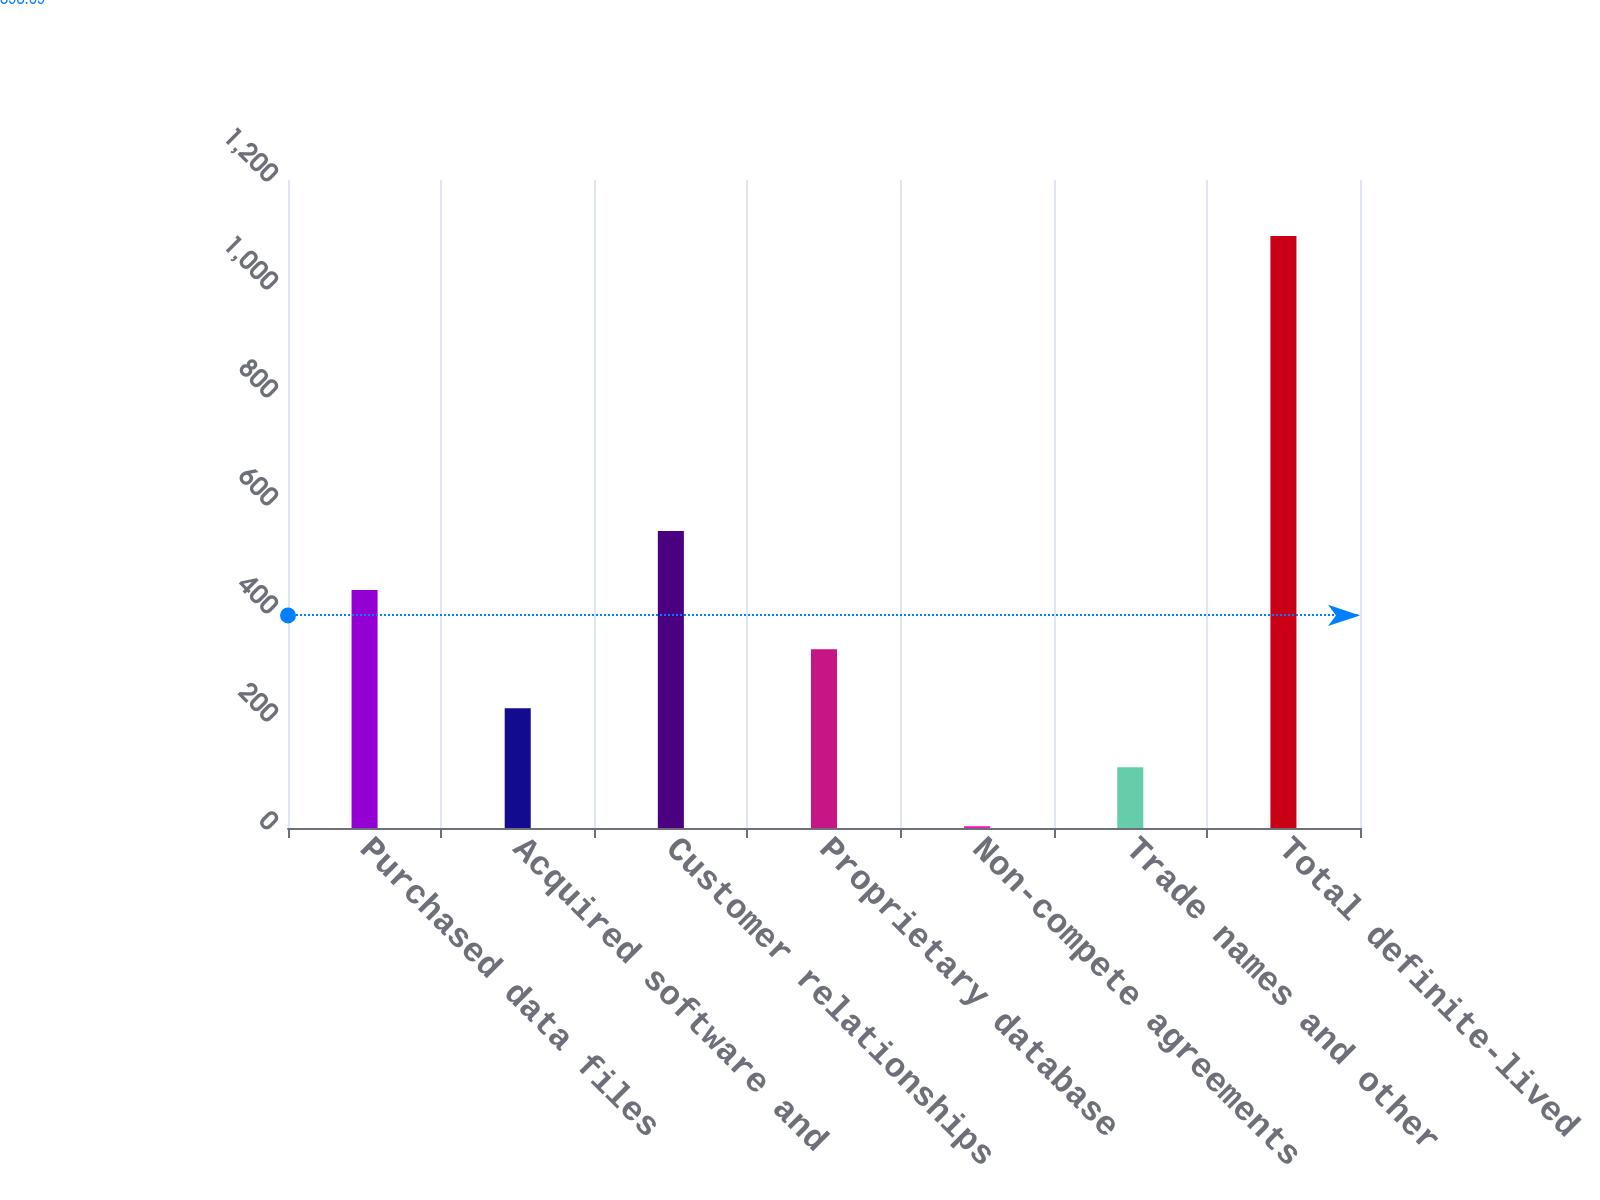Convert chart. <chart><loc_0><loc_0><loc_500><loc_500><bar_chart><fcel>Purchased data files<fcel>Acquired software and<fcel>Customer relationships<fcel>Proprietary database<fcel>Non-compete agreements<fcel>Trade names and other<fcel>Total definite-lived<nl><fcel>440.54<fcel>221.92<fcel>549.85<fcel>331.23<fcel>3.3<fcel>112.61<fcel>1096.4<nl></chart> 